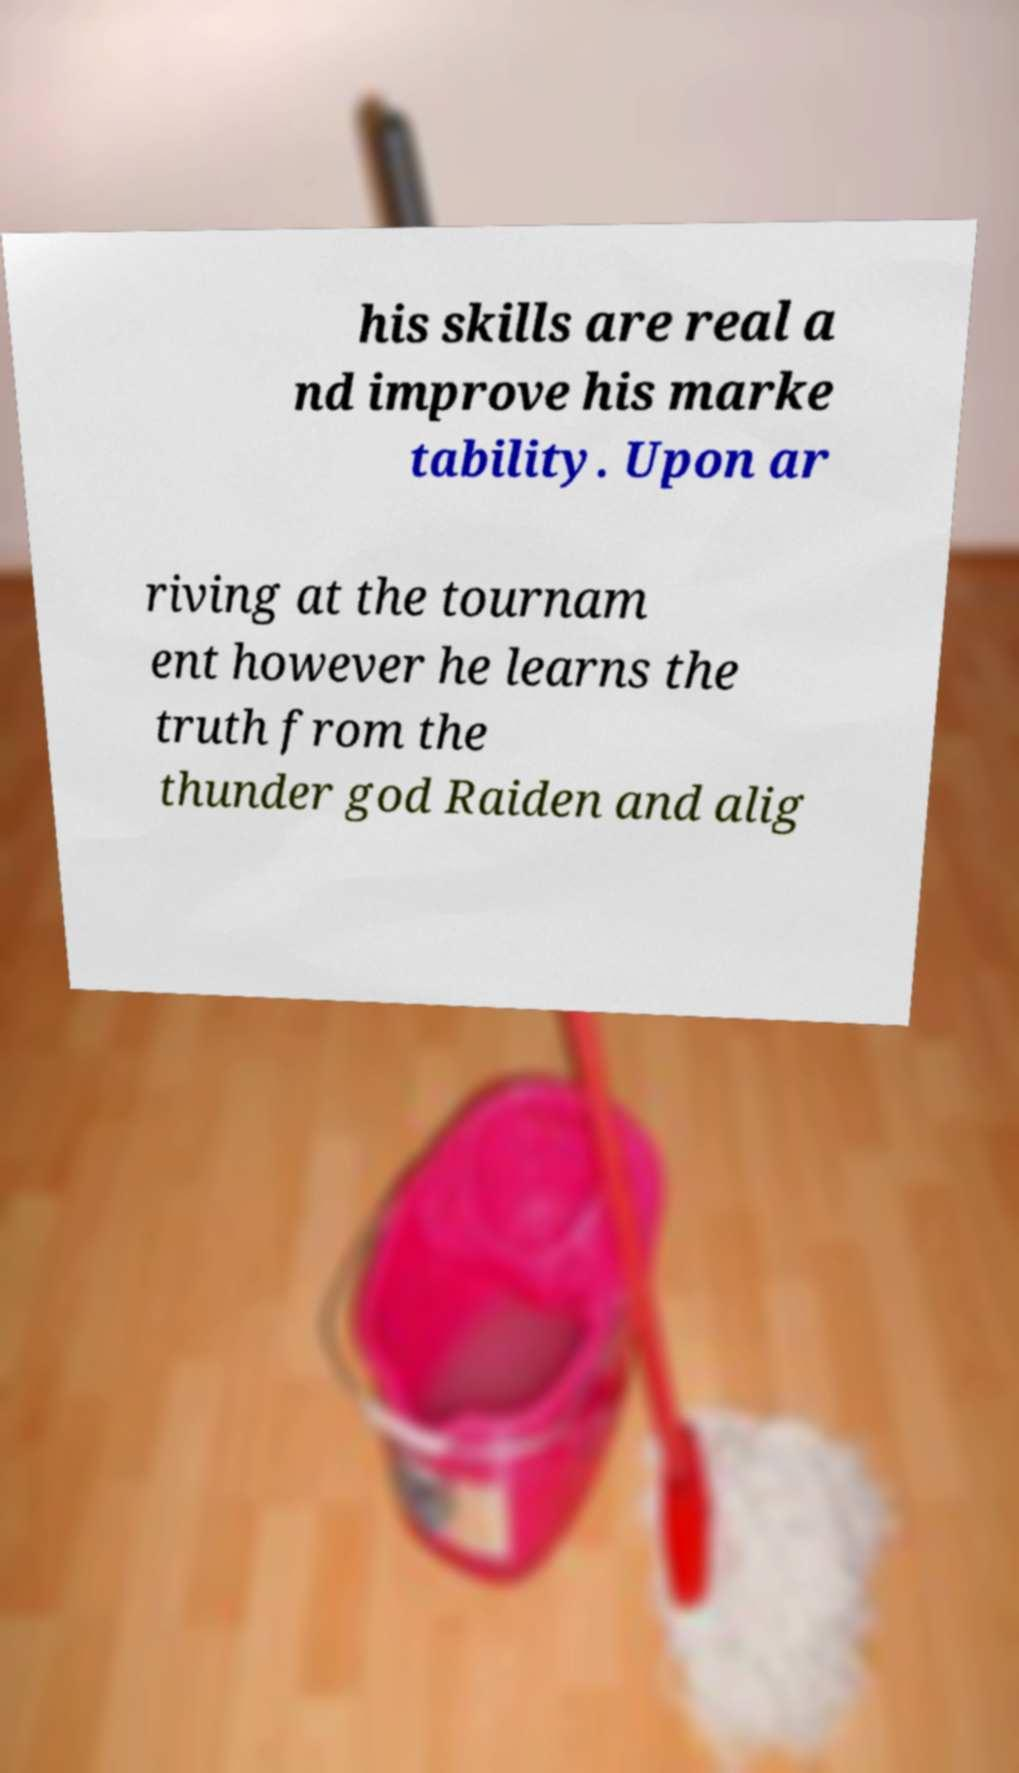Can you read and provide the text displayed in the image?This photo seems to have some interesting text. Can you extract and type it out for me? his skills are real a nd improve his marke tability. Upon ar riving at the tournam ent however he learns the truth from the thunder god Raiden and alig 